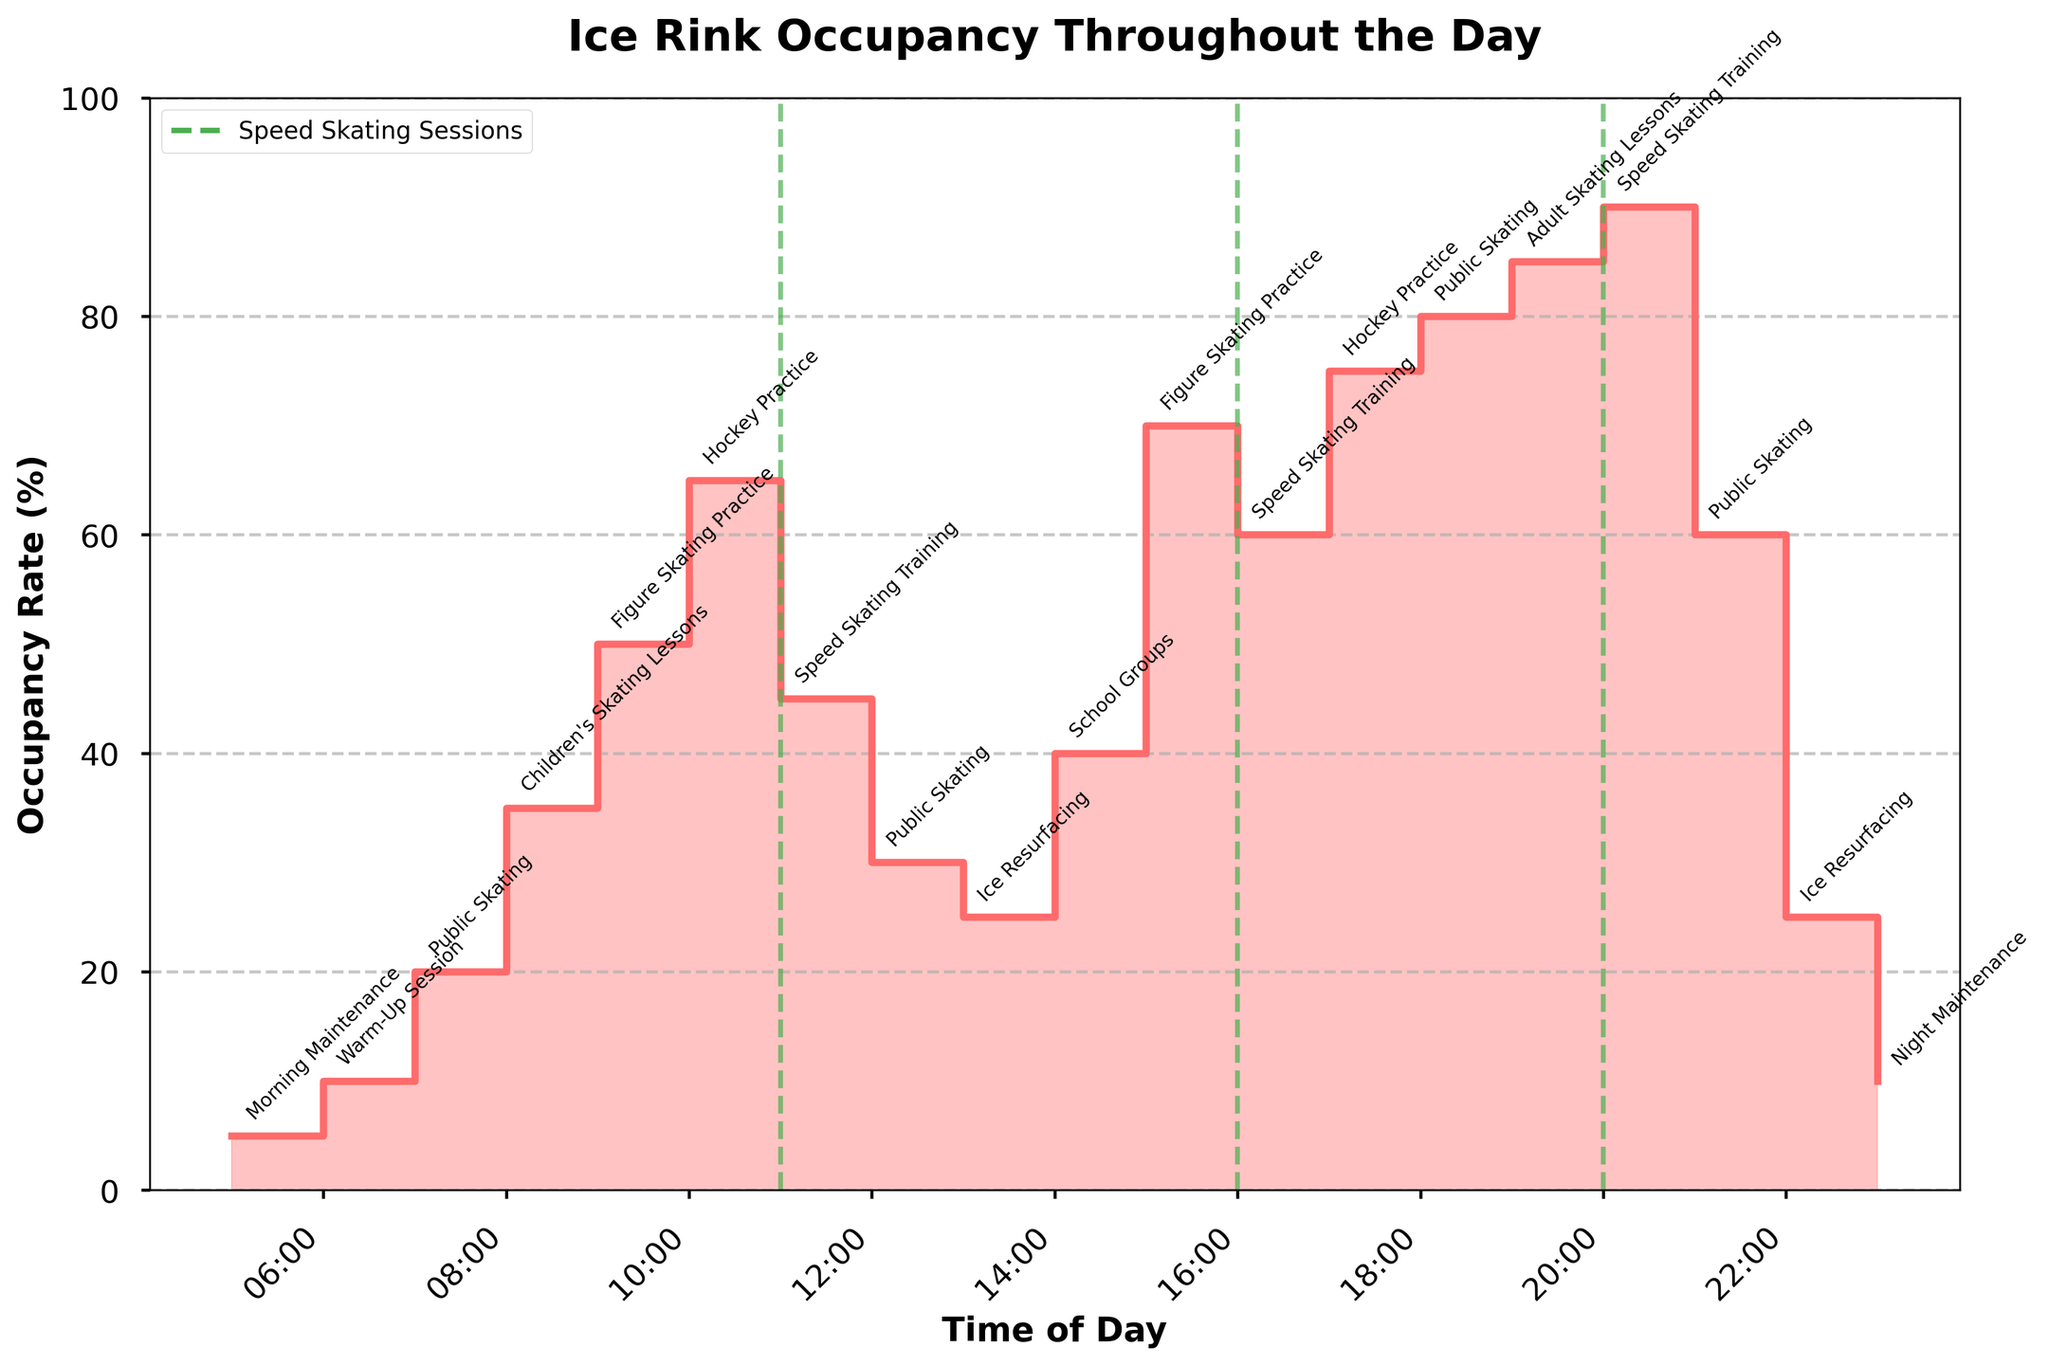What is the title of the stair plot? The title of the stair plot is displayed prominently at the top of the figure.
Answer: Ice Rink Occupancy Throughout the Day At what time does the maximum occupancy rate occur? Look for the highest point on the stair plot and identify the corresponding time on the x-axis.
Answer: 20:00 What is the occupancy rate at 17:00? Find the point on the plot corresponding to 17:00 on the x-axis and read the occupancy rate from the y-axis.
Answer: 75% How often are ice resurfacing activities scheduled throughout the day? Check the plot for times when the purpose is labeled as "Ice Resurfacing."
Answer: Twice During what activity does the occupancy rate first exceed 50%? Trace the stair plot from the lower occupancy rates upward and find the first activity where the occupancy rate is above 50%.
Answer: Hockey Practice Compare the occupancy rate during Speed Skating Training at 11:00 and at 16:00. Which one is higher? Identify the occupancy rate at 11:00 and 16:00 from the y-axis and compare them.
Answer: 16:00 How many times does Speed Skating Training occur throughout the day? Count the distinct times labeled as "Speed Skating Training" on the plot.
Answer: Three times What is the average occupancy rate during the Public Skating sessions? Identify the occupancy rates during all "Public Skating" sessions, sum them up and divide by the number of sessions.
Answer: (20 + 30 + 80 + 60) / 4 = 47.5% What time period has the lowest occupancy rate, and what is its purpose? Identify the lowest point on the plot and read the corresponding time and purpose.
Answer: 23:00, Night Maintenance What is the difference in occupancy rate between the Figure Skating Practice sessions at 9:00 and 15:00? Identify the occupancy rates at 9:00 and 15:00 from the y-axis and subtract the first from the second.
Answer: 70% - 50% = 20% 